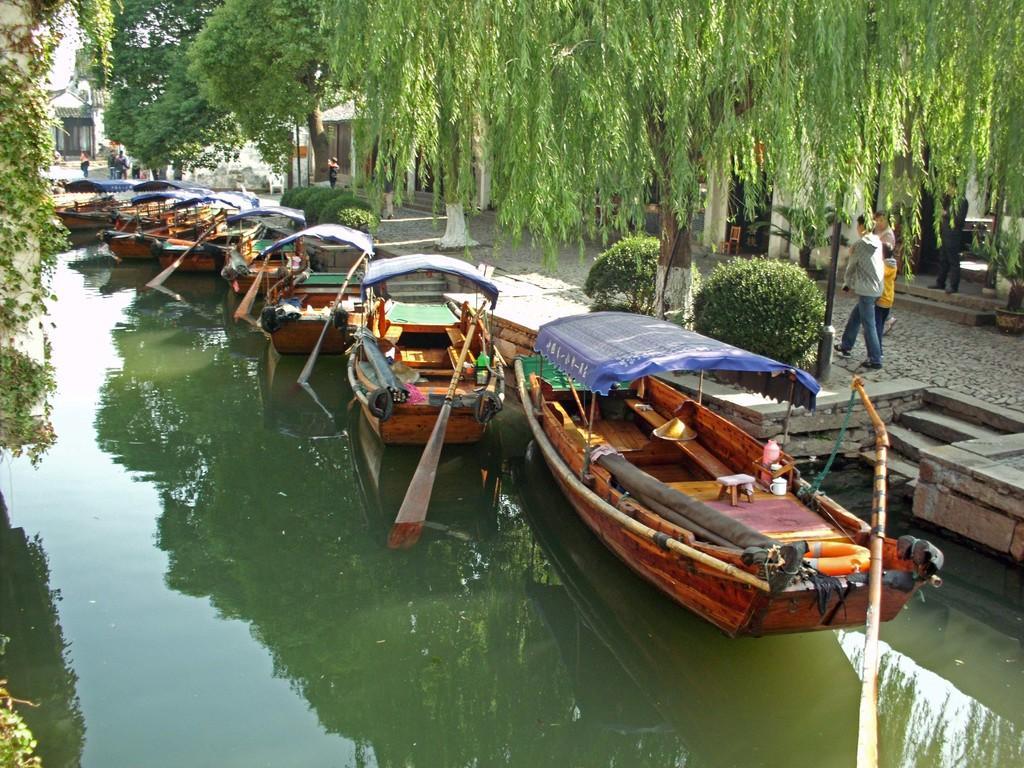Can you describe this image briefly? In this image in the front there is water and there are boats on the water. In the background there are trees, there are persons standing and there are buildings. 